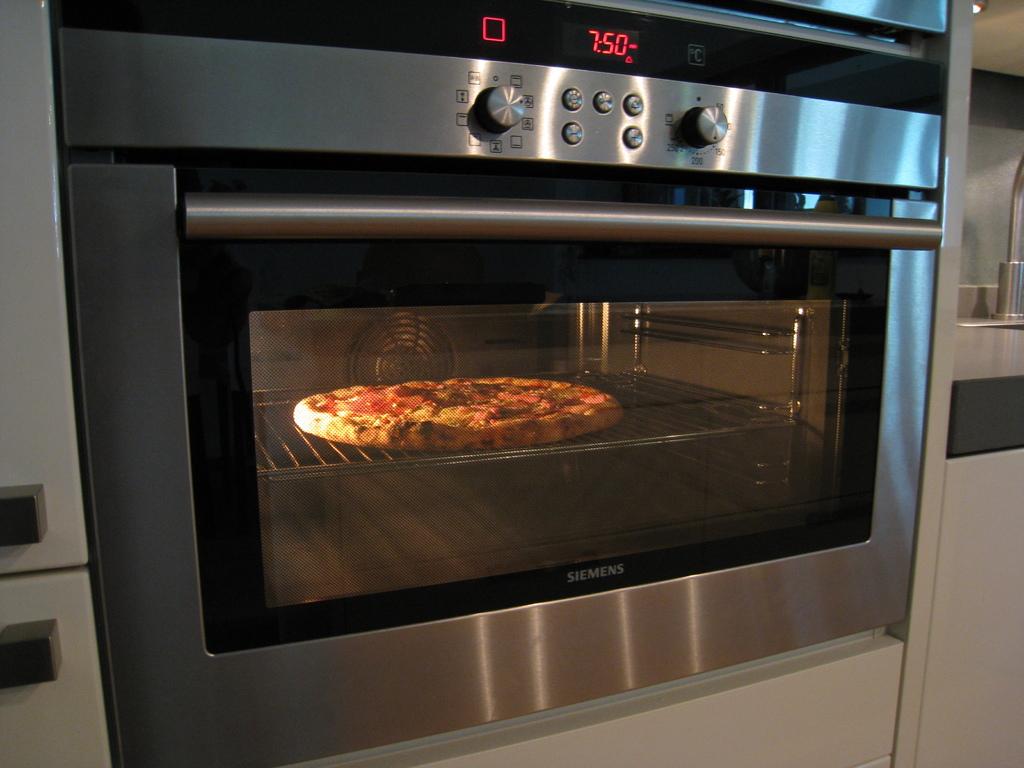What brand is this oven?
Make the answer very short. Siemens. What does the oven say?
Offer a terse response. 7:50. 